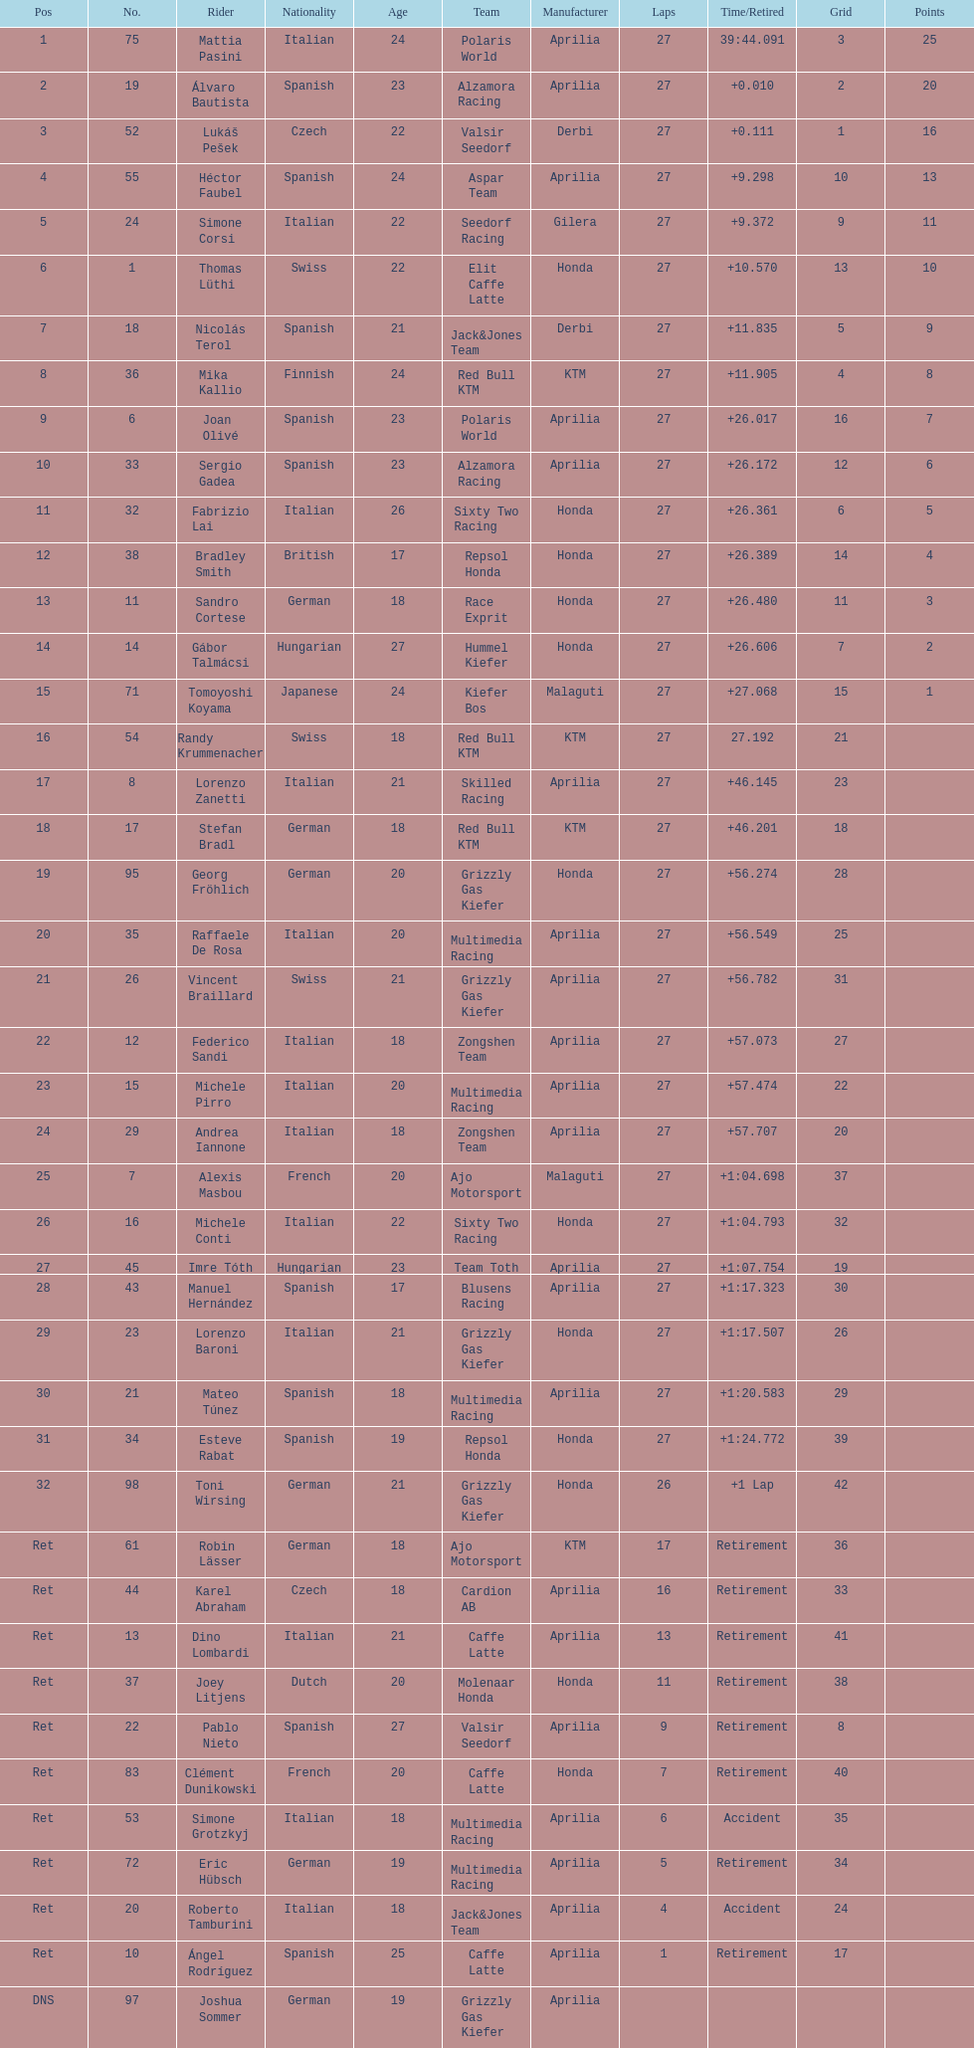Out of all the people who have points, who has the least? Tomoyoshi Koyama. 